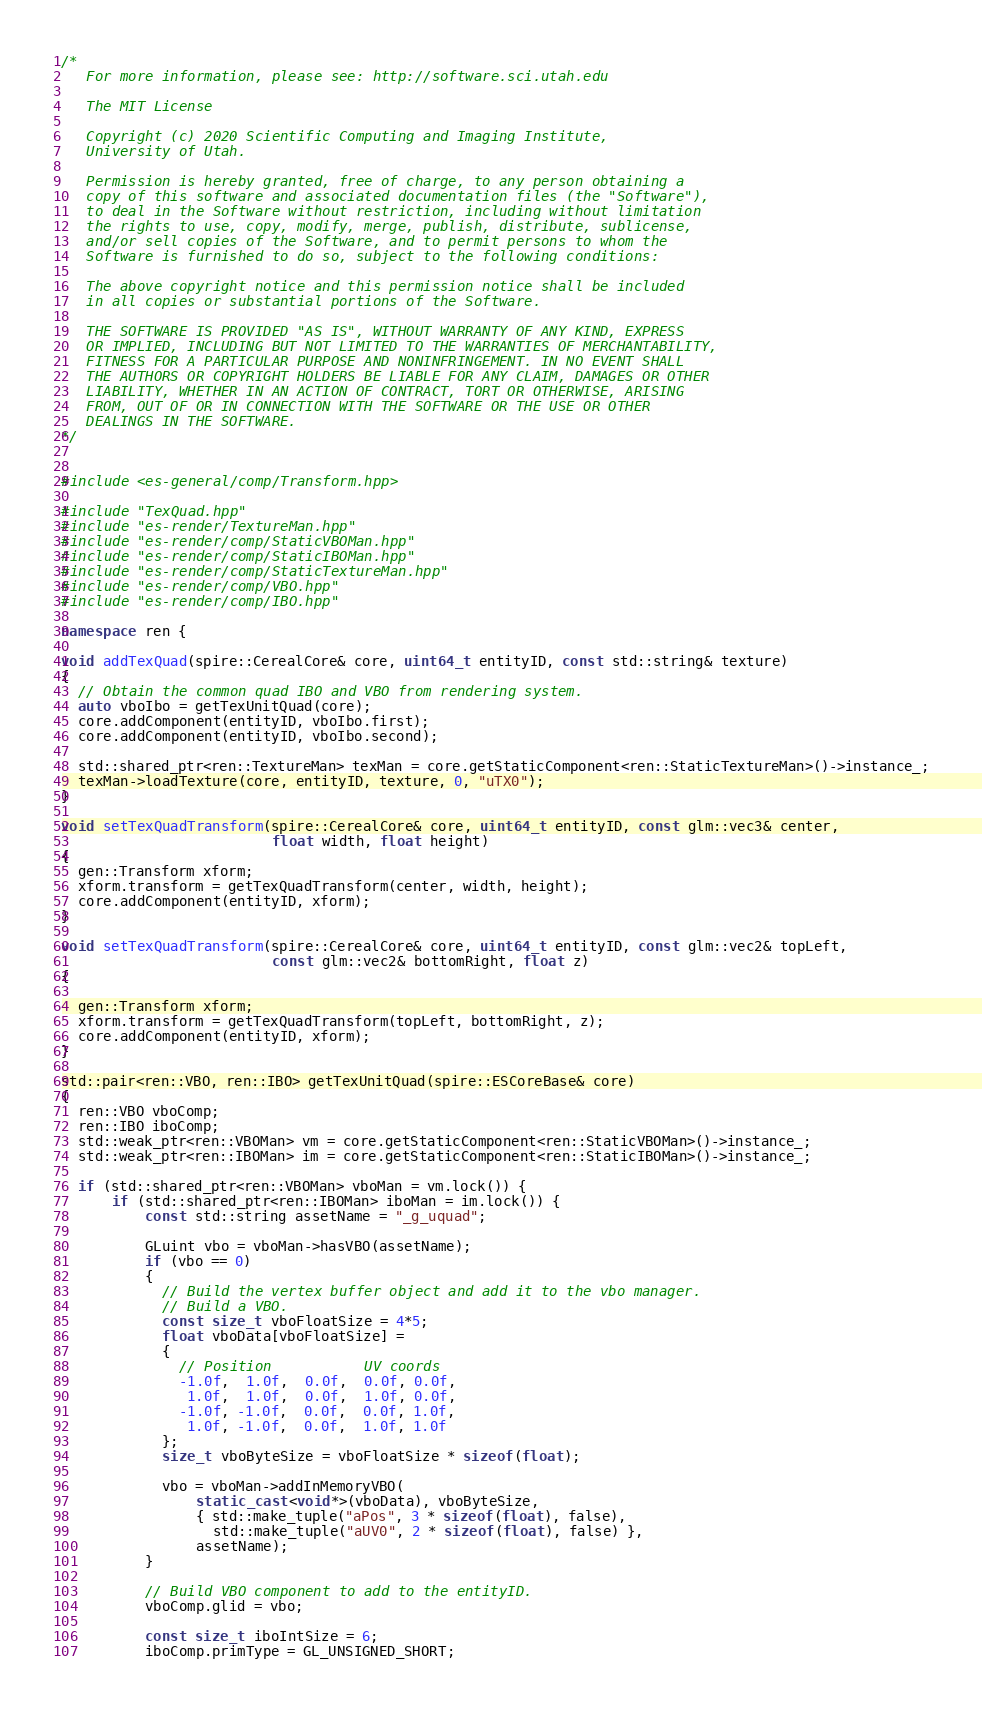<code> <loc_0><loc_0><loc_500><loc_500><_C++_>/*
   For more information, please see: http://software.sci.utah.edu

   The MIT License

   Copyright (c) 2020 Scientific Computing and Imaging Institute,
   University of Utah.

   Permission is hereby granted, free of charge, to any person obtaining a
   copy of this software and associated documentation files (the "Software"),
   to deal in the Software without restriction, including without limitation
   the rights to use, copy, modify, merge, publish, distribute, sublicense,
   and/or sell copies of the Software, and to permit persons to whom the
   Software is furnished to do so, subject to the following conditions:

   The above copyright notice and this permission notice shall be included
   in all copies or substantial portions of the Software.

   THE SOFTWARE IS PROVIDED "AS IS", WITHOUT WARRANTY OF ANY KIND, EXPRESS
   OR IMPLIED, INCLUDING BUT NOT LIMITED TO THE WARRANTIES OF MERCHANTABILITY,
   FITNESS FOR A PARTICULAR PURPOSE AND NONINFRINGEMENT. IN NO EVENT SHALL
   THE AUTHORS OR COPYRIGHT HOLDERS BE LIABLE FOR ANY CLAIM, DAMAGES OR OTHER
   LIABILITY, WHETHER IN AN ACTION OF CONTRACT, TORT OR OTHERWISE, ARISING
   FROM, OUT OF OR IN CONNECTION WITH THE SOFTWARE OR THE USE OR OTHER
   DEALINGS IN THE SOFTWARE.
*/


#include <es-general/comp/Transform.hpp>

#include "TexQuad.hpp"
#include "es-render/TextureMan.hpp"
#include "es-render/comp/StaticVBOMan.hpp"
#include "es-render/comp/StaticIBOMan.hpp"
#include "es-render/comp/StaticTextureMan.hpp"
#include "es-render/comp/VBO.hpp"
#include "es-render/comp/IBO.hpp"

namespace ren {

void addTexQuad(spire::CerealCore& core, uint64_t entityID, const std::string& texture)
{
  // Obtain the common quad IBO and VBO from rendering system.
  auto vboIbo = getTexUnitQuad(core);
  core.addComponent(entityID, vboIbo.first);
  core.addComponent(entityID, vboIbo.second);

  std::shared_ptr<ren::TextureMan> texMan = core.getStaticComponent<ren::StaticTextureMan>()->instance_;
  texMan->loadTexture(core, entityID, texture, 0, "uTX0");
}

void setTexQuadTransform(spire::CerealCore& core, uint64_t entityID, const glm::vec3& center,
                         float width, float height)
{
  gen::Transform xform;
  xform.transform = getTexQuadTransform(center, width, height);
  core.addComponent(entityID, xform);
}

void setTexQuadTransform(spire::CerealCore& core, uint64_t entityID, const glm::vec2& topLeft,
                         const glm::vec2& bottomRight, float z)
{

  gen::Transform xform;
  xform.transform = getTexQuadTransform(topLeft, bottomRight, z);
  core.addComponent(entityID, xform);
}

std::pair<ren::VBO, ren::IBO> getTexUnitQuad(spire::ESCoreBase& core)
{
  ren::VBO vboComp;
  ren::IBO iboComp;
  std::weak_ptr<ren::VBOMan> vm = core.getStaticComponent<ren::StaticVBOMan>()->instance_;
  std::weak_ptr<ren::IBOMan> im = core.getStaticComponent<ren::StaticIBOMan>()->instance_;

  if (std::shared_ptr<ren::VBOMan> vboMan = vm.lock()) {
      if (std::shared_ptr<ren::IBOMan> iboMan = im.lock()) {
          const std::string assetName = "_g_uquad";

          GLuint vbo = vboMan->hasVBO(assetName);
          if (vbo == 0)
          {
            // Build the vertex buffer object and add it to the vbo manager.
            // Build a VBO.
            const size_t vboFloatSize = 4*5;
            float vboData[vboFloatSize] =
            {
              // Position           UV coords
              -1.0f,  1.0f,  0.0f,  0.0f, 0.0f,
               1.0f,  1.0f,  0.0f,  1.0f, 0.0f,
              -1.0f, -1.0f,  0.0f,  0.0f, 1.0f,
               1.0f, -1.0f,  0.0f,  1.0f, 1.0f
            };
            size_t vboByteSize = vboFloatSize * sizeof(float);

            vbo = vboMan->addInMemoryVBO(
                static_cast<void*>(vboData), vboByteSize,
                { std::make_tuple("aPos", 3 * sizeof(float), false),
                  std::make_tuple("aUV0", 2 * sizeof(float), false) },
                assetName);
          }

          // Build VBO component to add to the entityID.
          vboComp.glid = vbo;

          const size_t iboIntSize = 6;
          iboComp.primType = GL_UNSIGNED_SHORT;</code> 